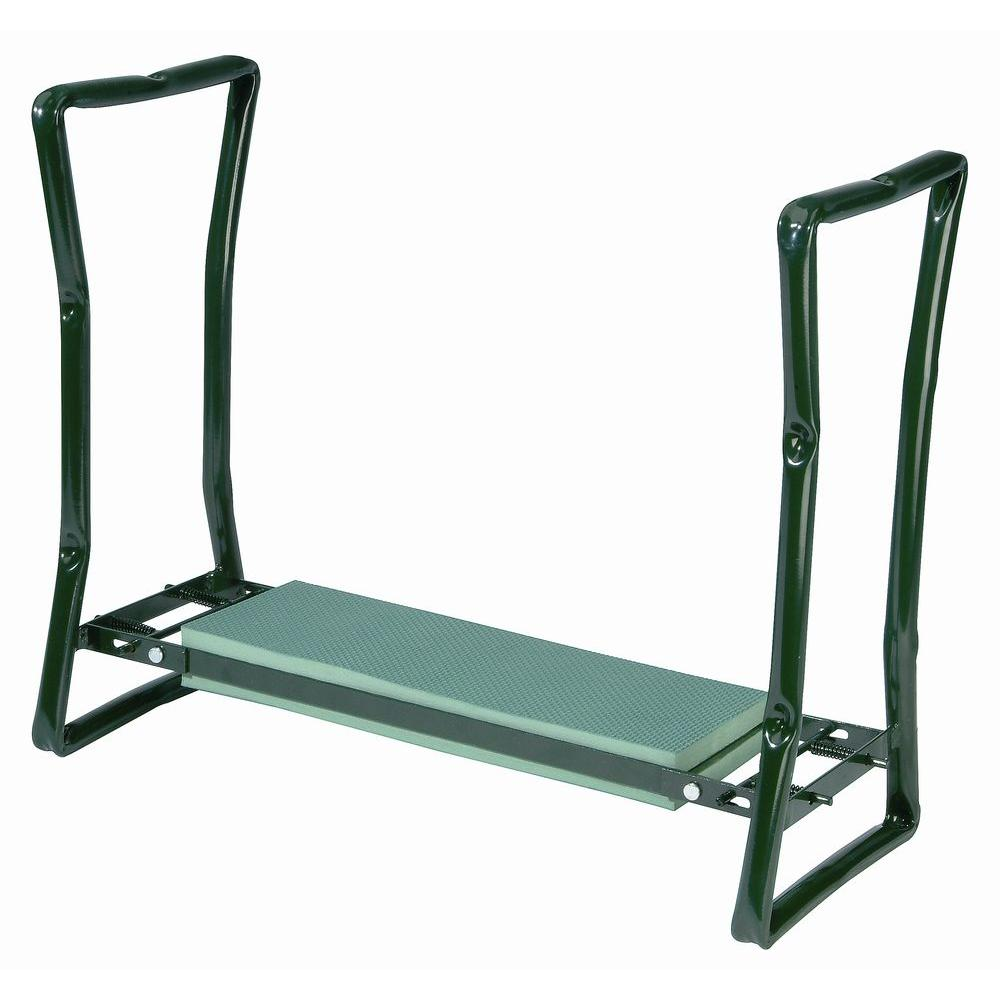What are the safety features visible in the design of this squat stand? The squat stand is equipped with several safety features. Firstly, the multiple holes along the vertical posts allow users to adjust the height of the barbell to a safe level that matches their height, reducing the risk of strain or injury. Secondly, the robust base provides stability to prevent tipping or wobbling during use. Additionally, the middle crossbar enhances the structural integrity of the stand, ensuring it remains steady and secure even under heavy loads. 